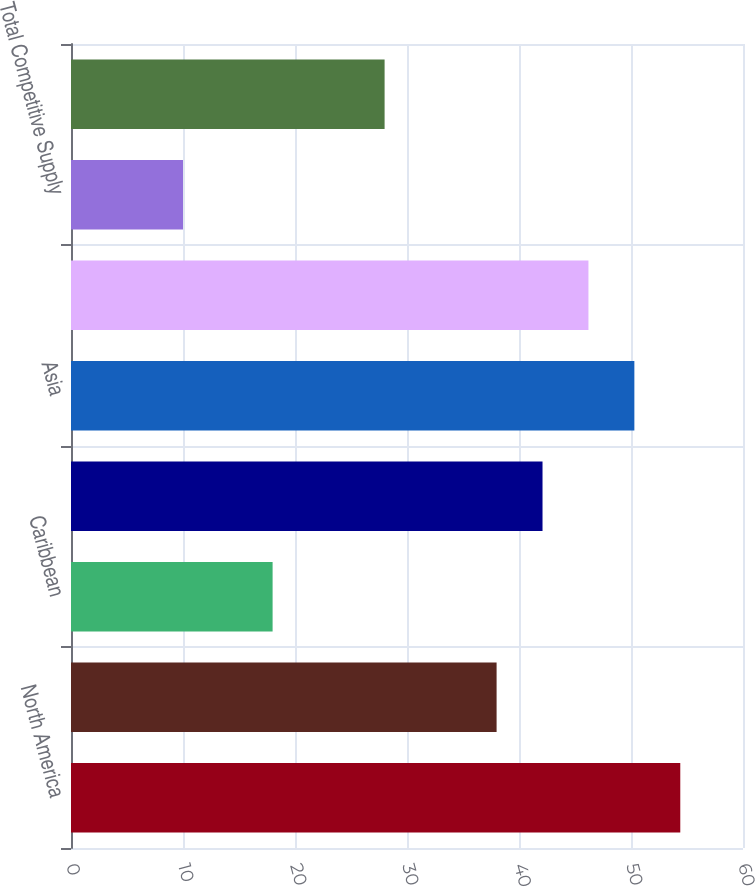Convert chart to OTSL. <chart><loc_0><loc_0><loc_500><loc_500><bar_chart><fcel>North America<fcel>South America<fcel>Caribbean<fcel>Europe/Africa<fcel>Asia<fcel>Total Contract Generation<fcel>Total Competitive Supply<fcel>Total Non-Regulated Gross<nl><fcel>54.4<fcel>38<fcel>18<fcel>42.1<fcel>50.3<fcel>46.2<fcel>10<fcel>28<nl></chart> 